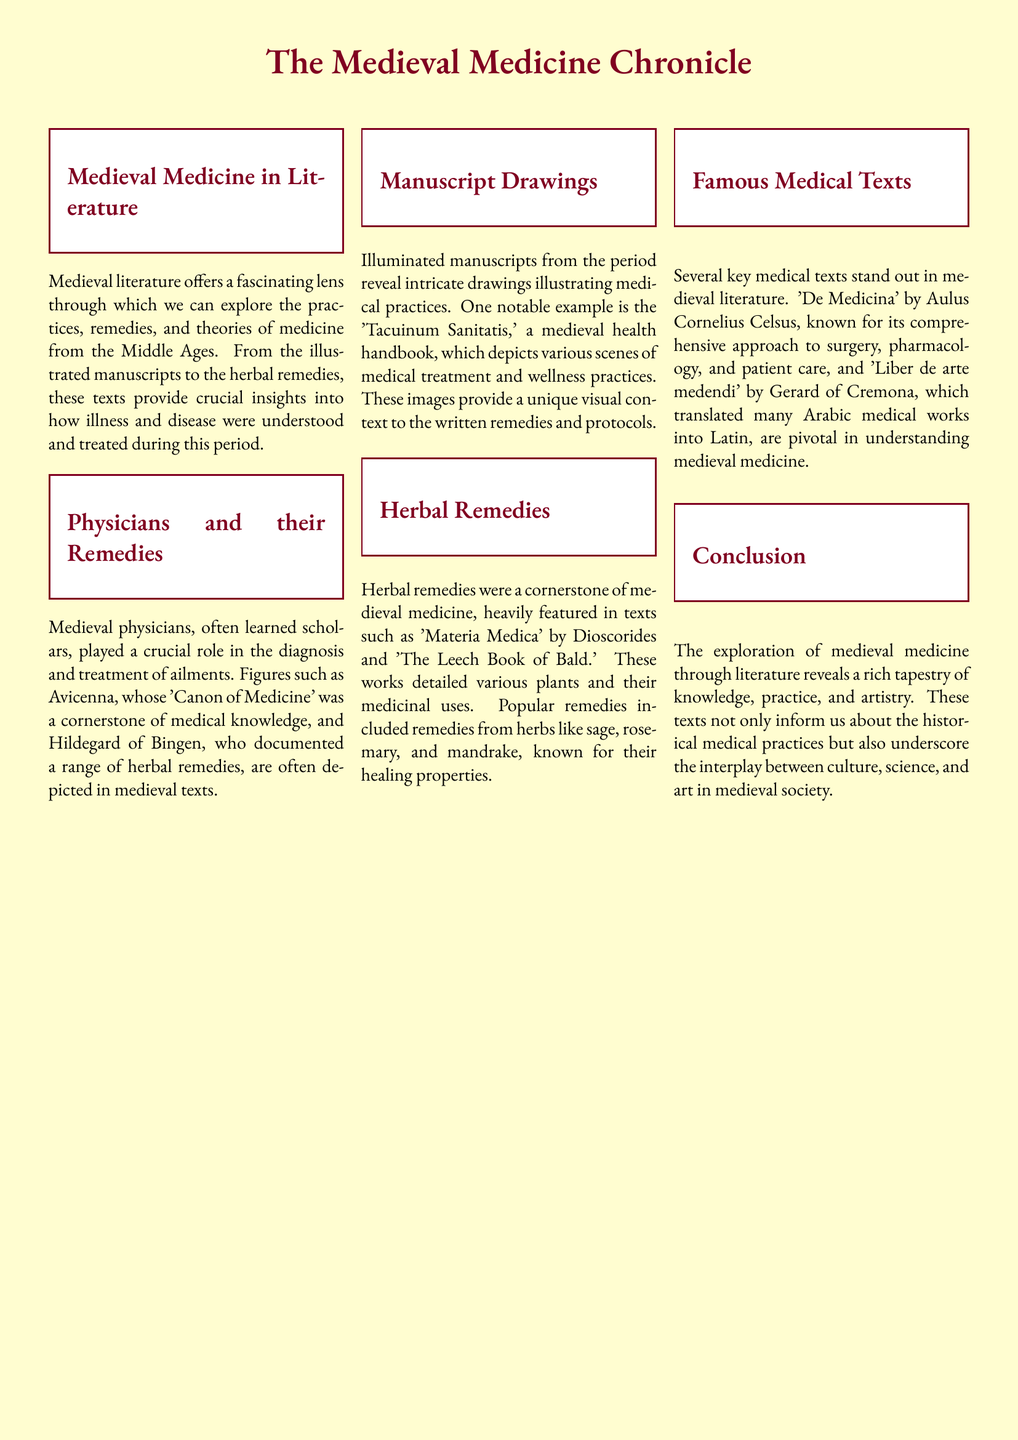What is the title of the document? The title is prominently displayed at the top and indicates the subject matter, which is focused on medieval medicine.
Answer: The Medieval Medicine Chronicle Who documented a range of herbal remedies? The document mentions a prominent figure known for her writings on herbal remedies within medieval texts.
Answer: Hildegard of Bingen What is the name of the health handbook mentioned? The document refers to a specific illustrated manuscript that serves as a health handbook in the medieval period.
Answer: Tacuinum Sanitatis Which herb is mentioned as having healing properties? A variety of herbs are listed in the document, highlighting their medicinal use.
Answer: Sage What type of medicine does 'De Medicina' focus on? The document specifies the area of medicine that Aulus Cornelius Celsus addresses in his work.
Answer: Surgery, pharmacology, and patient care What is a key feature of medieval manuscripts according to the text? The document highlights a particular aspect of medieval manuscripts that adds context to medical practices.
Answer: Illuminated drawings Which work translated many Arabic medical texts into Latin? This question addresses an important contribution to medieval medicine as noted in the text.
Answer: Liber de arte medendi 